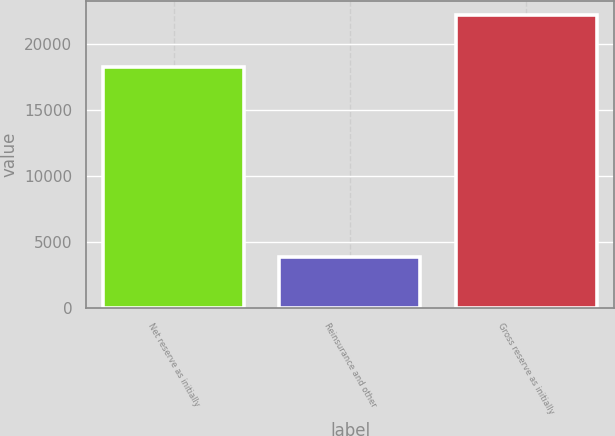Convert chart to OTSL. <chart><loc_0><loc_0><loc_500><loc_500><bar_chart><fcel>Net reserve as initially<fcel>Reinsurance and other<fcel>Gross reserve as initially<nl><fcel>18231<fcel>3922<fcel>22153<nl></chart> 